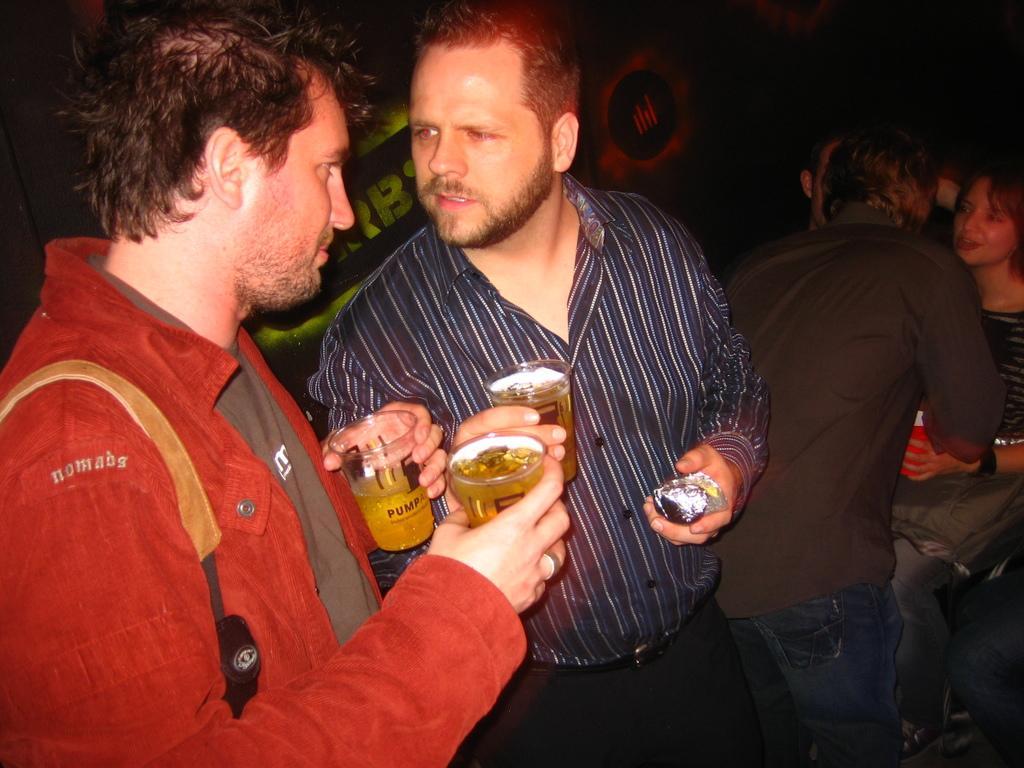Can you describe this image briefly? In front of the image there are two people holding the wine glasses. Beside them there are a few other people. In the background of the image there are screens. 